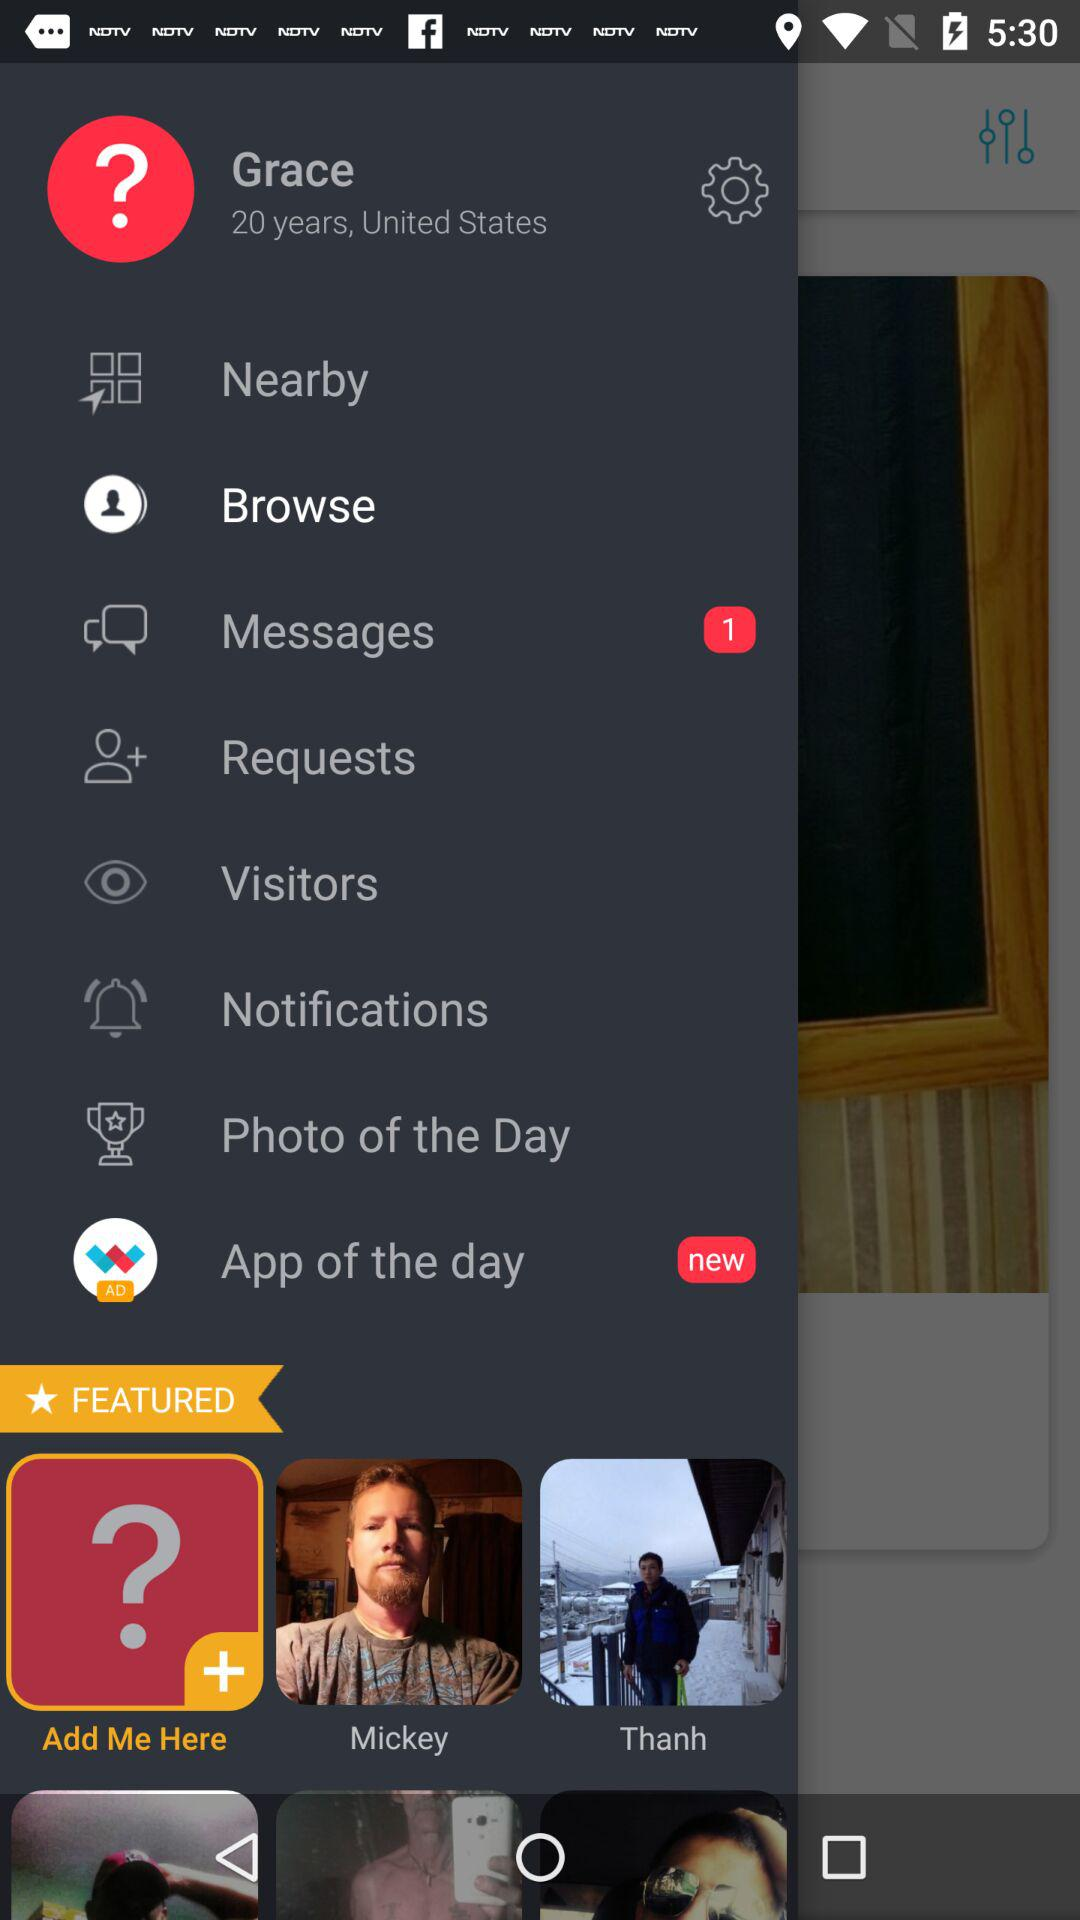What is new in app of the day?
When the provided information is insufficient, respond with <no answer>. <no answer> 